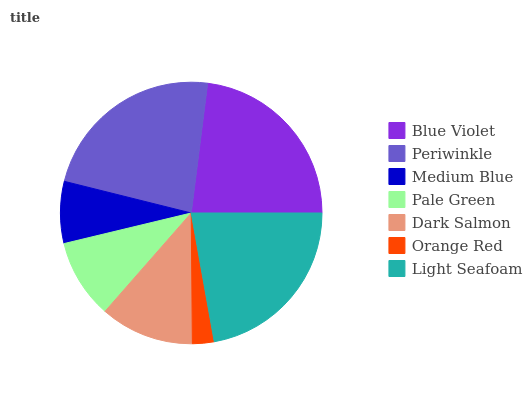Is Orange Red the minimum?
Answer yes or no. Yes. Is Periwinkle the maximum?
Answer yes or no. Yes. Is Medium Blue the minimum?
Answer yes or no. No. Is Medium Blue the maximum?
Answer yes or no. No. Is Periwinkle greater than Medium Blue?
Answer yes or no. Yes. Is Medium Blue less than Periwinkle?
Answer yes or no. Yes. Is Medium Blue greater than Periwinkle?
Answer yes or no. No. Is Periwinkle less than Medium Blue?
Answer yes or no. No. Is Dark Salmon the high median?
Answer yes or no. Yes. Is Dark Salmon the low median?
Answer yes or no. Yes. Is Pale Green the high median?
Answer yes or no. No. Is Medium Blue the low median?
Answer yes or no. No. 